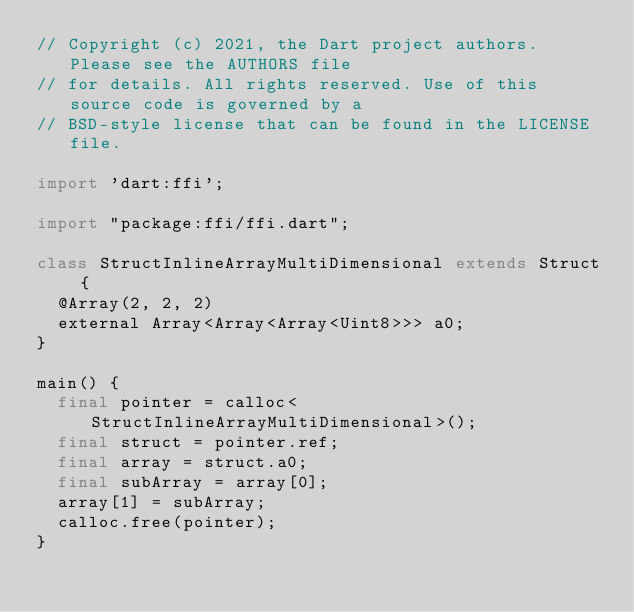<code> <loc_0><loc_0><loc_500><loc_500><_Dart_>// Copyright (c) 2021, the Dart project authors.  Please see the AUTHORS file
// for details. All rights reserved. Use of this source code is governed by a
// BSD-style license that can be found in the LICENSE file.

import 'dart:ffi';

import "package:ffi/ffi.dart";

class StructInlineArrayMultiDimensional extends Struct {
  @Array(2, 2, 2)
  external Array<Array<Array<Uint8>>> a0;
}

main() {
  final pointer = calloc<StructInlineArrayMultiDimensional>();
  final struct = pointer.ref;
  final array = struct.a0;
  final subArray = array[0];
  array[1] = subArray;
  calloc.free(pointer);
}
</code> 